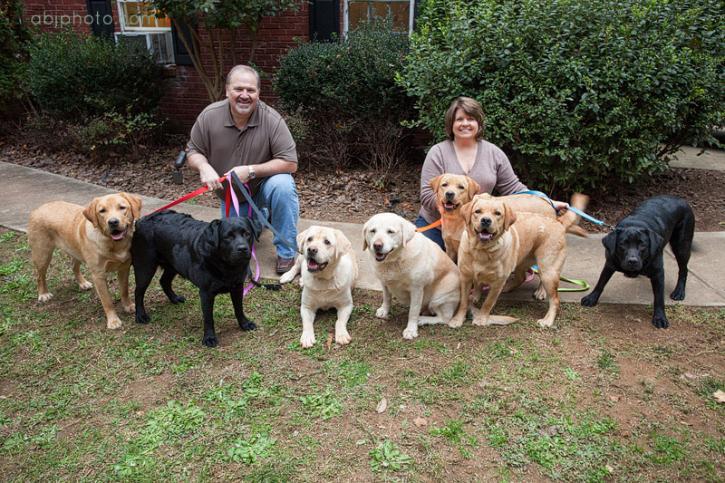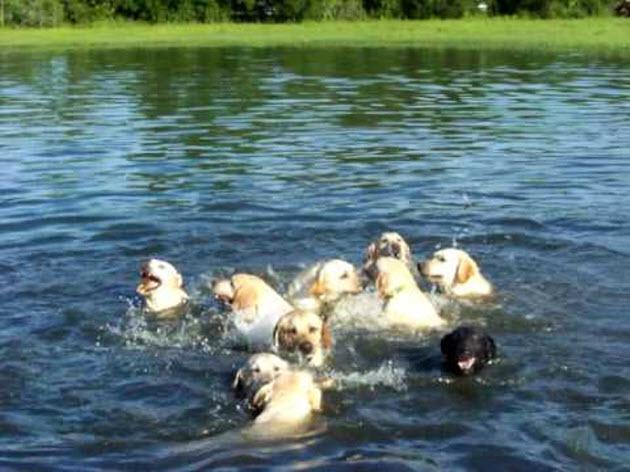The first image is the image on the left, the second image is the image on the right. Considering the images on both sides, is "Some of the dogs are in the water, and only one dog near the water is not """"blond""""." valid? Answer yes or no. Yes. The first image is the image on the left, the second image is the image on the right. Examine the images to the left and right. Is the description "The dogs in the image on the right are near the water." accurate? Answer yes or no. Yes. 